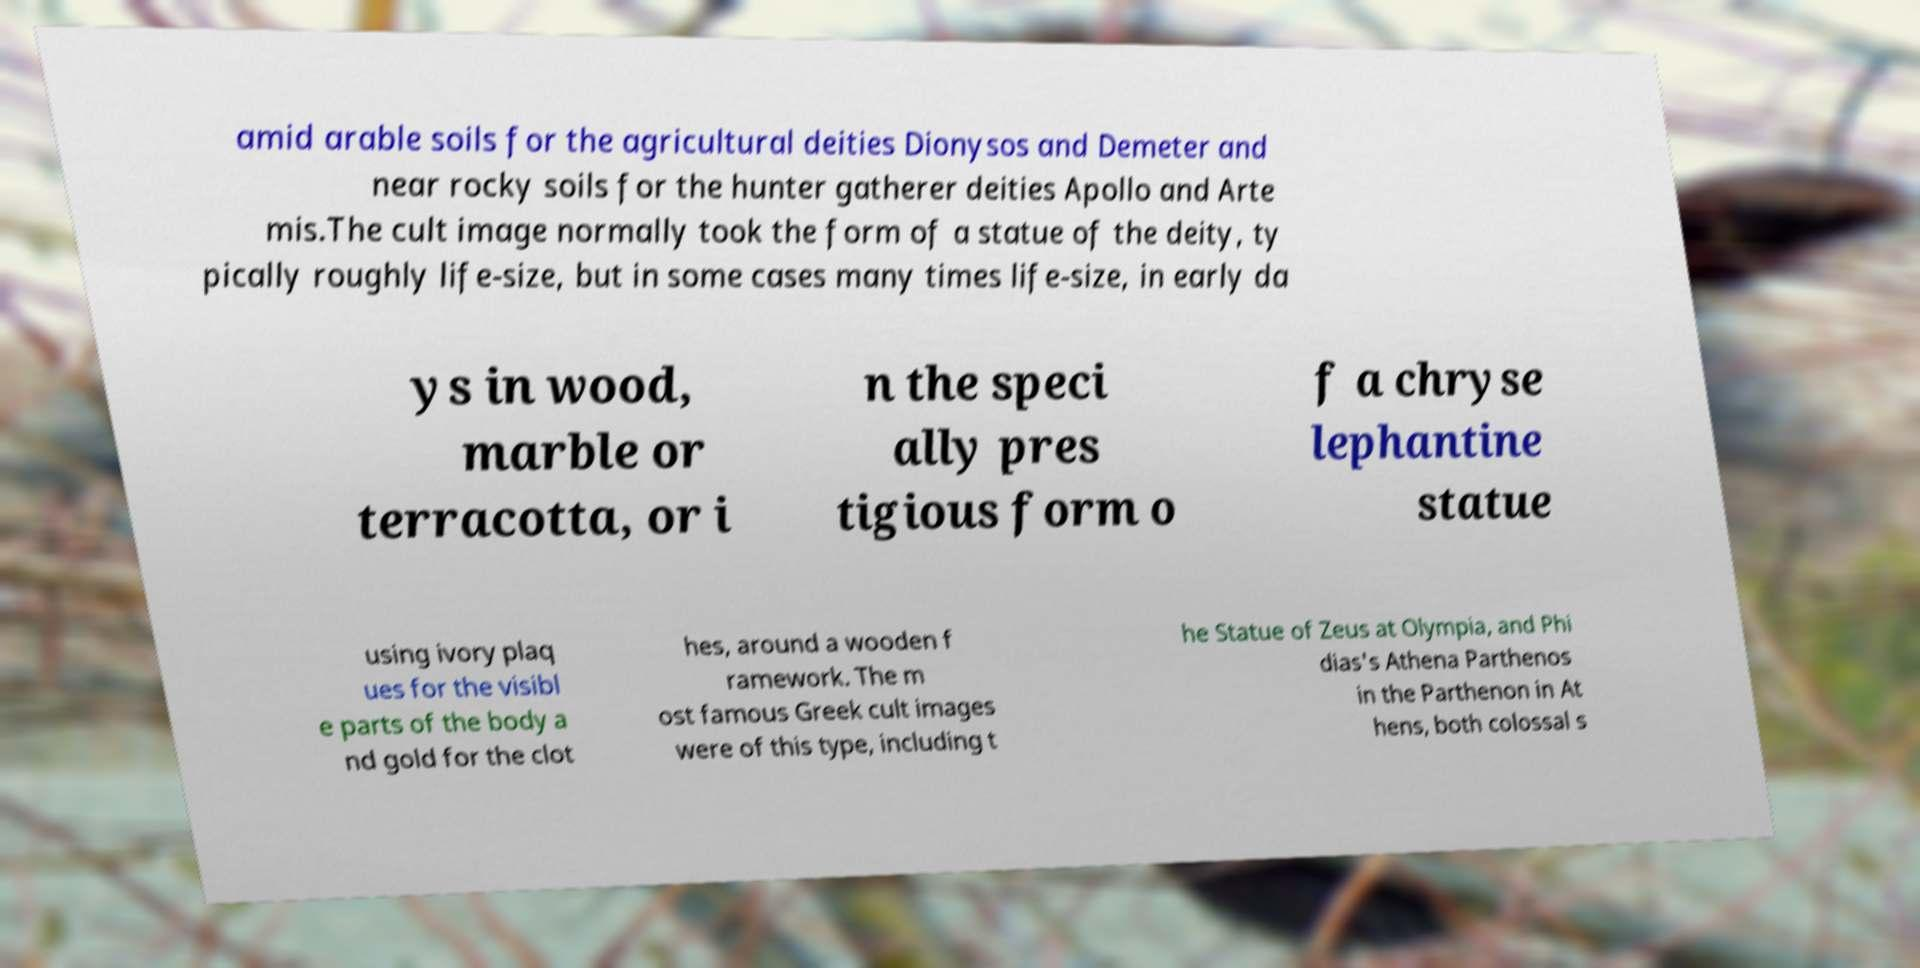Could you extract and type out the text from this image? amid arable soils for the agricultural deities Dionysos and Demeter and near rocky soils for the hunter gatherer deities Apollo and Arte mis.The cult image normally took the form of a statue of the deity, ty pically roughly life-size, but in some cases many times life-size, in early da ys in wood, marble or terracotta, or i n the speci ally pres tigious form o f a chryse lephantine statue using ivory plaq ues for the visibl e parts of the body a nd gold for the clot hes, around a wooden f ramework. The m ost famous Greek cult images were of this type, including t he Statue of Zeus at Olympia, and Phi dias's Athena Parthenos in the Parthenon in At hens, both colossal s 